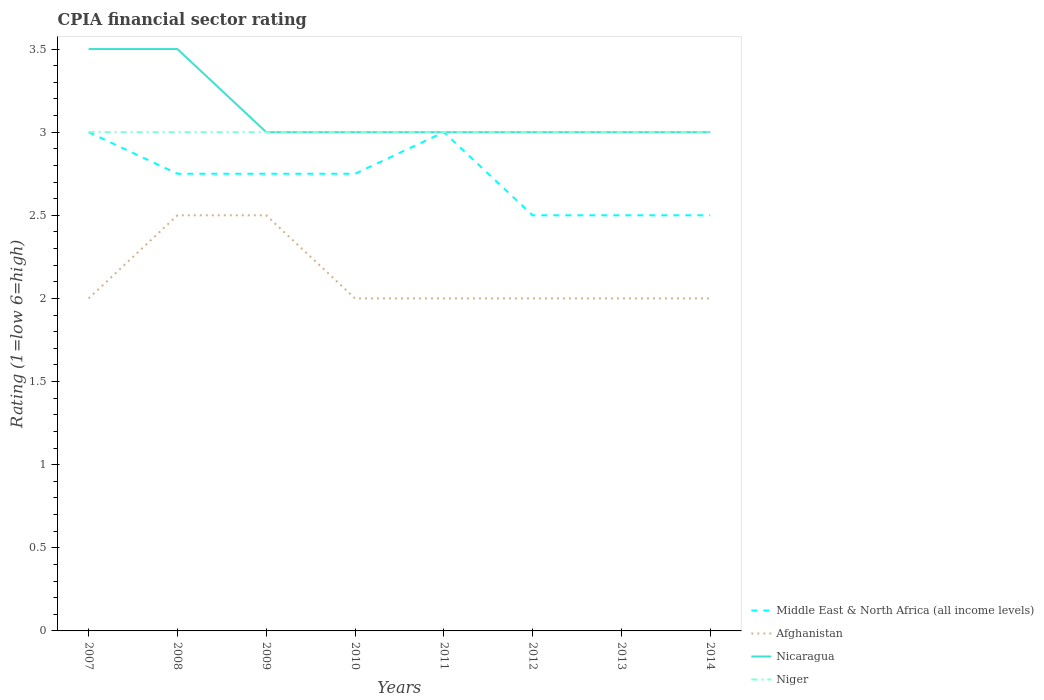How many different coloured lines are there?
Provide a succinct answer. 4. Does the line corresponding to Middle East & North Africa (all income levels) intersect with the line corresponding to Nicaragua?
Give a very brief answer. Yes. Is the number of lines equal to the number of legend labels?
Make the answer very short. Yes. Across all years, what is the maximum CPIA rating in Afghanistan?
Offer a terse response. 2. In which year was the CPIA rating in Nicaragua maximum?
Your response must be concise. 2009. What is the total CPIA rating in Niger in the graph?
Your answer should be compact. 0. Is the CPIA rating in Afghanistan strictly greater than the CPIA rating in Niger over the years?
Offer a terse response. Yes. How many lines are there?
Provide a succinct answer. 4. How many years are there in the graph?
Your response must be concise. 8. Are the values on the major ticks of Y-axis written in scientific E-notation?
Keep it short and to the point. No. Does the graph contain grids?
Your answer should be very brief. No. Where does the legend appear in the graph?
Give a very brief answer. Bottom right. What is the title of the graph?
Keep it short and to the point. CPIA financial sector rating. Does "Luxembourg" appear as one of the legend labels in the graph?
Offer a terse response. No. What is the label or title of the X-axis?
Offer a very short reply. Years. What is the label or title of the Y-axis?
Ensure brevity in your answer.  Rating (1=low 6=high). What is the Rating (1=low 6=high) in Middle East & North Africa (all income levels) in 2007?
Offer a terse response. 3. What is the Rating (1=low 6=high) in Afghanistan in 2007?
Ensure brevity in your answer.  2. What is the Rating (1=low 6=high) of Nicaragua in 2007?
Keep it short and to the point. 3.5. What is the Rating (1=low 6=high) of Middle East & North Africa (all income levels) in 2008?
Your answer should be compact. 2.75. What is the Rating (1=low 6=high) of Afghanistan in 2008?
Provide a succinct answer. 2.5. What is the Rating (1=low 6=high) of Nicaragua in 2008?
Your answer should be compact. 3.5. What is the Rating (1=low 6=high) of Middle East & North Africa (all income levels) in 2009?
Give a very brief answer. 2.75. What is the Rating (1=low 6=high) of Middle East & North Africa (all income levels) in 2010?
Make the answer very short. 2.75. What is the Rating (1=low 6=high) of Afghanistan in 2010?
Offer a very short reply. 2. What is the Rating (1=low 6=high) of Nicaragua in 2010?
Your response must be concise. 3. What is the Rating (1=low 6=high) in Niger in 2010?
Provide a succinct answer. 3. What is the Rating (1=low 6=high) of Afghanistan in 2011?
Provide a succinct answer. 2. What is the Rating (1=low 6=high) in Nicaragua in 2011?
Offer a terse response. 3. What is the Rating (1=low 6=high) in Middle East & North Africa (all income levels) in 2012?
Provide a succinct answer. 2.5. What is the Rating (1=low 6=high) of Nicaragua in 2012?
Offer a very short reply. 3. What is the Rating (1=low 6=high) in Nicaragua in 2013?
Keep it short and to the point. 3. What is the Rating (1=low 6=high) of Middle East & North Africa (all income levels) in 2014?
Ensure brevity in your answer.  2.5. What is the Rating (1=low 6=high) of Afghanistan in 2014?
Make the answer very short. 2. What is the Rating (1=low 6=high) in Nicaragua in 2014?
Your response must be concise. 3. Across all years, what is the maximum Rating (1=low 6=high) in Middle East & North Africa (all income levels)?
Give a very brief answer. 3. Across all years, what is the minimum Rating (1=low 6=high) in Afghanistan?
Your answer should be compact. 2. What is the total Rating (1=low 6=high) of Middle East & North Africa (all income levels) in the graph?
Provide a short and direct response. 21.75. What is the total Rating (1=low 6=high) of Afghanistan in the graph?
Your answer should be very brief. 17. What is the difference between the Rating (1=low 6=high) in Afghanistan in 2007 and that in 2008?
Offer a very short reply. -0.5. What is the difference between the Rating (1=low 6=high) in Nicaragua in 2007 and that in 2008?
Offer a terse response. 0. What is the difference between the Rating (1=low 6=high) of Niger in 2007 and that in 2008?
Offer a terse response. 0. What is the difference between the Rating (1=low 6=high) of Middle East & North Africa (all income levels) in 2007 and that in 2009?
Keep it short and to the point. 0.25. What is the difference between the Rating (1=low 6=high) of Niger in 2007 and that in 2009?
Give a very brief answer. 0. What is the difference between the Rating (1=low 6=high) in Middle East & North Africa (all income levels) in 2007 and that in 2010?
Your answer should be compact. 0.25. What is the difference between the Rating (1=low 6=high) of Afghanistan in 2007 and that in 2010?
Provide a succinct answer. 0. What is the difference between the Rating (1=low 6=high) of Niger in 2007 and that in 2010?
Provide a succinct answer. 0. What is the difference between the Rating (1=low 6=high) of Middle East & North Africa (all income levels) in 2007 and that in 2011?
Your response must be concise. 0. What is the difference between the Rating (1=low 6=high) of Afghanistan in 2007 and that in 2011?
Ensure brevity in your answer.  0. What is the difference between the Rating (1=low 6=high) in Afghanistan in 2007 and that in 2012?
Your answer should be compact. 0. What is the difference between the Rating (1=low 6=high) of Niger in 2007 and that in 2012?
Your answer should be compact. 0. What is the difference between the Rating (1=low 6=high) of Afghanistan in 2007 and that in 2013?
Keep it short and to the point. 0. What is the difference between the Rating (1=low 6=high) in Middle East & North Africa (all income levels) in 2007 and that in 2014?
Offer a terse response. 0.5. What is the difference between the Rating (1=low 6=high) of Afghanistan in 2007 and that in 2014?
Provide a short and direct response. 0. What is the difference between the Rating (1=low 6=high) in Nicaragua in 2007 and that in 2014?
Give a very brief answer. 0.5. What is the difference between the Rating (1=low 6=high) of Niger in 2007 and that in 2014?
Offer a terse response. 0. What is the difference between the Rating (1=low 6=high) in Nicaragua in 2008 and that in 2009?
Your response must be concise. 0.5. What is the difference between the Rating (1=low 6=high) in Middle East & North Africa (all income levels) in 2008 and that in 2010?
Your answer should be very brief. 0. What is the difference between the Rating (1=low 6=high) in Nicaragua in 2008 and that in 2010?
Your answer should be compact. 0.5. What is the difference between the Rating (1=low 6=high) in Niger in 2008 and that in 2010?
Make the answer very short. 0. What is the difference between the Rating (1=low 6=high) in Middle East & North Africa (all income levels) in 2008 and that in 2011?
Offer a very short reply. -0.25. What is the difference between the Rating (1=low 6=high) of Afghanistan in 2008 and that in 2011?
Your answer should be very brief. 0.5. What is the difference between the Rating (1=low 6=high) of Nicaragua in 2008 and that in 2011?
Ensure brevity in your answer.  0.5. What is the difference between the Rating (1=low 6=high) in Niger in 2008 and that in 2011?
Offer a terse response. 0. What is the difference between the Rating (1=low 6=high) of Middle East & North Africa (all income levels) in 2008 and that in 2013?
Make the answer very short. 0.25. What is the difference between the Rating (1=low 6=high) in Afghanistan in 2008 and that in 2014?
Ensure brevity in your answer.  0.5. What is the difference between the Rating (1=low 6=high) in Nicaragua in 2008 and that in 2014?
Provide a short and direct response. 0.5. What is the difference between the Rating (1=low 6=high) in Niger in 2008 and that in 2014?
Your response must be concise. 0. What is the difference between the Rating (1=low 6=high) of Afghanistan in 2009 and that in 2010?
Provide a succinct answer. 0.5. What is the difference between the Rating (1=low 6=high) in Niger in 2009 and that in 2010?
Keep it short and to the point. 0. What is the difference between the Rating (1=low 6=high) of Middle East & North Africa (all income levels) in 2009 and that in 2011?
Your response must be concise. -0.25. What is the difference between the Rating (1=low 6=high) of Nicaragua in 2009 and that in 2011?
Give a very brief answer. 0. What is the difference between the Rating (1=low 6=high) of Afghanistan in 2009 and that in 2012?
Make the answer very short. 0.5. What is the difference between the Rating (1=low 6=high) of Nicaragua in 2009 and that in 2012?
Provide a short and direct response. 0. What is the difference between the Rating (1=low 6=high) of Afghanistan in 2009 and that in 2013?
Your response must be concise. 0.5. What is the difference between the Rating (1=low 6=high) in Nicaragua in 2009 and that in 2013?
Give a very brief answer. 0. What is the difference between the Rating (1=low 6=high) in Afghanistan in 2009 and that in 2014?
Ensure brevity in your answer.  0.5. What is the difference between the Rating (1=low 6=high) in Nicaragua in 2009 and that in 2014?
Your response must be concise. 0. What is the difference between the Rating (1=low 6=high) in Middle East & North Africa (all income levels) in 2010 and that in 2011?
Your response must be concise. -0.25. What is the difference between the Rating (1=low 6=high) of Afghanistan in 2010 and that in 2011?
Provide a succinct answer. 0. What is the difference between the Rating (1=low 6=high) in Afghanistan in 2010 and that in 2012?
Keep it short and to the point. 0. What is the difference between the Rating (1=low 6=high) in Niger in 2010 and that in 2012?
Offer a very short reply. 0. What is the difference between the Rating (1=low 6=high) of Middle East & North Africa (all income levels) in 2010 and that in 2013?
Keep it short and to the point. 0.25. What is the difference between the Rating (1=low 6=high) of Afghanistan in 2010 and that in 2013?
Your answer should be very brief. 0. What is the difference between the Rating (1=low 6=high) of Nicaragua in 2010 and that in 2014?
Keep it short and to the point. 0. What is the difference between the Rating (1=low 6=high) of Niger in 2011 and that in 2012?
Your answer should be compact. 0. What is the difference between the Rating (1=low 6=high) in Afghanistan in 2011 and that in 2013?
Offer a very short reply. 0. What is the difference between the Rating (1=low 6=high) in Nicaragua in 2011 and that in 2013?
Your answer should be compact. 0. What is the difference between the Rating (1=low 6=high) of Middle East & North Africa (all income levels) in 2011 and that in 2014?
Offer a terse response. 0.5. What is the difference between the Rating (1=low 6=high) in Afghanistan in 2011 and that in 2014?
Your response must be concise. 0. What is the difference between the Rating (1=low 6=high) of Nicaragua in 2011 and that in 2014?
Give a very brief answer. 0. What is the difference between the Rating (1=low 6=high) of Niger in 2011 and that in 2014?
Ensure brevity in your answer.  0. What is the difference between the Rating (1=low 6=high) in Afghanistan in 2012 and that in 2013?
Your answer should be very brief. 0. What is the difference between the Rating (1=low 6=high) in Niger in 2012 and that in 2013?
Offer a very short reply. 0. What is the difference between the Rating (1=low 6=high) in Afghanistan in 2012 and that in 2014?
Provide a short and direct response. 0. What is the difference between the Rating (1=low 6=high) in Nicaragua in 2012 and that in 2014?
Provide a short and direct response. 0. What is the difference between the Rating (1=low 6=high) of Afghanistan in 2013 and that in 2014?
Your answer should be very brief. 0. What is the difference between the Rating (1=low 6=high) in Nicaragua in 2013 and that in 2014?
Your answer should be very brief. 0. What is the difference between the Rating (1=low 6=high) of Middle East & North Africa (all income levels) in 2007 and the Rating (1=low 6=high) of Niger in 2008?
Your response must be concise. 0. What is the difference between the Rating (1=low 6=high) in Afghanistan in 2007 and the Rating (1=low 6=high) in Niger in 2008?
Your answer should be compact. -1. What is the difference between the Rating (1=low 6=high) of Middle East & North Africa (all income levels) in 2007 and the Rating (1=low 6=high) of Afghanistan in 2009?
Ensure brevity in your answer.  0.5. What is the difference between the Rating (1=low 6=high) in Afghanistan in 2007 and the Rating (1=low 6=high) in Nicaragua in 2009?
Offer a terse response. -1. What is the difference between the Rating (1=low 6=high) of Afghanistan in 2007 and the Rating (1=low 6=high) of Niger in 2009?
Your answer should be very brief. -1. What is the difference between the Rating (1=low 6=high) of Nicaragua in 2007 and the Rating (1=low 6=high) of Niger in 2009?
Your answer should be compact. 0.5. What is the difference between the Rating (1=low 6=high) of Middle East & North Africa (all income levels) in 2007 and the Rating (1=low 6=high) of Niger in 2010?
Make the answer very short. 0. What is the difference between the Rating (1=low 6=high) in Afghanistan in 2007 and the Rating (1=low 6=high) in Nicaragua in 2010?
Offer a very short reply. -1. What is the difference between the Rating (1=low 6=high) in Nicaragua in 2007 and the Rating (1=low 6=high) in Niger in 2010?
Your response must be concise. 0.5. What is the difference between the Rating (1=low 6=high) in Middle East & North Africa (all income levels) in 2007 and the Rating (1=low 6=high) in Nicaragua in 2011?
Your answer should be very brief. 0. What is the difference between the Rating (1=low 6=high) of Afghanistan in 2007 and the Rating (1=low 6=high) of Nicaragua in 2011?
Your response must be concise. -1. What is the difference between the Rating (1=low 6=high) in Nicaragua in 2007 and the Rating (1=low 6=high) in Niger in 2011?
Give a very brief answer. 0.5. What is the difference between the Rating (1=low 6=high) in Middle East & North Africa (all income levels) in 2007 and the Rating (1=low 6=high) in Nicaragua in 2012?
Your response must be concise. 0. What is the difference between the Rating (1=low 6=high) of Afghanistan in 2007 and the Rating (1=low 6=high) of Nicaragua in 2012?
Offer a terse response. -1. What is the difference between the Rating (1=low 6=high) of Middle East & North Africa (all income levels) in 2007 and the Rating (1=low 6=high) of Nicaragua in 2013?
Provide a succinct answer. 0. What is the difference between the Rating (1=low 6=high) of Middle East & North Africa (all income levels) in 2007 and the Rating (1=low 6=high) of Nicaragua in 2014?
Make the answer very short. 0. What is the difference between the Rating (1=low 6=high) of Middle East & North Africa (all income levels) in 2007 and the Rating (1=low 6=high) of Niger in 2014?
Provide a short and direct response. 0. What is the difference between the Rating (1=low 6=high) of Afghanistan in 2007 and the Rating (1=low 6=high) of Nicaragua in 2014?
Your response must be concise. -1. What is the difference between the Rating (1=low 6=high) in Afghanistan in 2007 and the Rating (1=low 6=high) in Niger in 2014?
Offer a terse response. -1. What is the difference between the Rating (1=low 6=high) in Nicaragua in 2007 and the Rating (1=low 6=high) in Niger in 2014?
Your response must be concise. 0.5. What is the difference between the Rating (1=low 6=high) of Middle East & North Africa (all income levels) in 2008 and the Rating (1=low 6=high) of Nicaragua in 2009?
Offer a very short reply. -0.25. What is the difference between the Rating (1=low 6=high) in Afghanistan in 2008 and the Rating (1=low 6=high) in Niger in 2009?
Give a very brief answer. -0.5. What is the difference between the Rating (1=low 6=high) of Middle East & North Africa (all income levels) in 2008 and the Rating (1=low 6=high) of Nicaragua in 2010?
Ensure brevity in your answer.  -0.25. What is the difference between the Rating (1=low 6=high) of Middle East & North Africa (all income levels) in 2008 and the Rating (1=low 6=high) of Niger in 2010?
Provide a succinct answer. -0.25. What is the difference between the Rating (1=low 6=high) of Afghanistan in 2008 and the Rating (1=low 6=high) of Nicaragua in 2010?
Your answer should be very brief. -0.5. What is the difference between the Rating (1=low 6=high) in Afghanistan in 2008 and the Rating (1=low 6=high) in Niger in 2010?
Offer a terse response. -0.5. What is the difference between the Rating (1=low 6=high) in Middle East & North Africa (all income levels) in 2008 and the Rating (1=low 6=high) in Afghanistan in 2011?
Ensure brevity in your answer.  0.75. What is the difference between the Rating (1=low 6=high) of Middle East & North Africa (all income levels) in 2008 and the Rating (1=low 6=high) of Nicaragua in 2011?
Ensure brevity in your answer.  -0.25. What is the difference between the Rating (1=low 6=high) of Middle East & North Africa (all income levels) in 2008 and the Rating (1=low 6=high) of Niger in 2011?
Offer a very short reply. -0.25. What is the difference between the Rating (1=low 6=high) in Afghanistan in 2008 and the Rating (1=low 6=high) in Niger in 2012?
Offer a very short reply. -0.5. What is the difference between the Rating (1=low 6=high) in Middle East & North Africa (all income levels) in 2008 and the Rating (1=low 6=high) in Nicaragua in 2013?
Keep it short and to the point. -0.25. What is the difference between the Rating (1=low 6=high) of Afghanistan in 2008 and the Rating (1=low 6=high) of Nicaragua in 2013?
Provide a short and direct response. -0.5. What is the difference between the Rating (1=low 6=high) in Afghanistan in 2008 and the Rating (1=low 6=high) in Niger in 2013?
Make the answer very short. -0.5. What is the difference between the Rating (1=low 6=high) of Nicaragua in 2008 and the Rating (1=low 6=high) of Niger in 2013?
Offer a terse response. 0.5. What is the difference between the Rating (1=low 6=high) of Middle East & North Africa (all income levels) in 2008 and the Rating (1=low 6=high) of Afghanistan in 2014?
Offer a very short reply. 0.75. What is the difference between the Rating (1=low 6=high) of Middle East & North Africa (all income levels) in 2008 and the Rating (1=low 6=high) of Nicaragua in 2014?
Provide a short and direct response. -0.25. What is the difference between the Rating (1=low 6=high) of Middle East & North Africa (all income levels) in 2008 and the Rating (1=low 6=high) of Niger in 2014?
Provide a short and direct response. -0.25. What is the difference between the Rating (1=low 6=high) in Nicaragua in 2008 and the Rating (1=low 6=high) in Niger in 2014?
Provide a short and direct response. 0.5. What is the difference between the Rating (1=low 6=high) of Middle East & North Africa (all income levels) in 2009 and the Rating (1=low 6=high) of Nicaragua in 2010?
Offer a terse response. -0.25. What is the difference between the Rating (1=low 6=high) of Afghanistan in 2009 and the Rating (1=low 6=high) of Niger in 2010?
Offer a terse response. -0.5. What is the difference between the Rating (1=low 6=high) of Nicaragua in 2009 and the Rating (1=low 6=high) of Niger in 2010?
Make the answer very short. 0. What is the difference between the Rating (1=low 6=high) of Middle East & North Africa (all income levels) in 2009 and the Rating (1=low 6=high) of Afghanistan in 2011?
Offer a terse response. 0.75. What is the difference between the Rating (1=low 6=high) of Middle East & North Africa (all income levels) in 2009 and the Rating (1=low 6=high) of Nicaragua in 2011?
Provide a succinct answer. -0.25. What is the difference between the Rating (1=low 6=high) in Afghanistan in 2009 and the Rating (1=low 6=high) in Nicaragua in 2011?
Provide a succinct answer. -0.5. What is the difference between the Rating (1=low 6=high) in Afghanistan in 2009 and the Rating (1=low 6=high) in Niger in 2011?
Your answer should be very brief. -0.5. What is the difference between the Rating (1=low 6=high) of Nicaragua in 2009 and the Rating (1=low 6=high) of Niger in 2011?
Keep it short and to the point. 0. What is the difference between the Rating (1=low 6=high) in Middle East & North Africa (all income levels) in 2009 and the Rating (1=low 6=high) in Afghanistan in 2012?
Offer a very short reply. 0.75. What is the difference between the Rating (1=low 6=high) in Middle East & North Africa (all income levels) in 2009 and the Rating (1=low 6=high) in Nicaragua in 2012?
Offer a terse response. -0.25. What is the difference between the Rating (1=low 6=high) of Middle East & North Africa (all income levels) in 2009 and the Rating (1=low 6=high) of Niger in 2012?
Give a very brief answer. -0.25. What is the difference between the Rating (1=low 6=high) of Afghanistan in 2009 and the Rating (1=low 6=high) of Nicaragua in 2012?
Your answer should be compact. -0.5. What is the difference between the Rating (1=low 6=high) of Nicaragua in 2009 and the Rating (1=low 6=high) of Niger in 2012?
Offer a very short reply. 0. What is the difference between the Rating (1=low 6=high) in Middle East & North Africa (all income levels) in 2009 and the Rating (1=low 6=high) in Afghanistan in 2013?
Your answer should be very brief. 0.75. What is the difference between the Rating (1=low 6=high) of Middle East & North Africa (all income levels) in 2009 and the Rating (1=low 6=high) of Nicaragua in 2013?
Your response must be concise. -0.25. What is the difference between the Rating (1=low 6=high) of Middle East & North Africa (all income levels) in 2009 and the Rating (1=low 6=high) of Niger in 2013?
Your response must be concise. -0.25. What is the difference between the Rating (1=low 6=high) of Afghanistan in 2009 and the Rating (1=low 6=high) of Nicaragua in 2013?
Keep it short and to the point. -0.5. What is the difference between the Rating (1=low 6=high) in Nicaragua in 2009 and the Rating (1=low 6=high) in Niger in 2013?
Offer a terse response. 0. What is the difference between the Rating (1=low 6=high) of Middle East & North Africa (all income levels) in 2009 and the Rating (1=low 6=high) of Niger in 2014?
Your answer should be very brief. -0.25. What is the difference between the Rating (1=low 6=high) in Middle East & North Africa (all income levels) in 2010 and the Rating (1=low 6=high) in Nicaragua in 2011?
Provide a short and direct response. -0.25. What is the difference between the Rating (1=low 6=high) in Middle East & North Africa (all income levels) in 2010 and the Rating (1=low 6=high) in Niger in 2011?
Provide a short and direct response. -0.25. What is the difference between the Rating (1=low 6=high) of Afghanistan in 2010 and the Rating (1=low 6=high) of Niger in 2011?
Your answer should be very brief. -1. What is the difference between the Rating (1=low 6=high) of Middle East & North Africa (all income levels) in 2010 and the Rating (1=low 6=high) of Niger in 2012?
Offer a terse response. -0.25. What is the difference between the Rating (1=low 6=high) of Afghanistan in 2010 and the Rating (1=low 6=high) of Nicaragua in 2012?
Keep it short and to the point. -1. What is the difference between the Rating (1=low 6=high) of Nicaragua in 2010 and the Rating (1=low 6=high) of Niger in 2012?
Your response must be concise. 0. What is the difference between the Rating (1=low 6=high) of Middle East & North Africa (all income levels) in 2010 and the Rating (1=low 6=high) of Afghanistan in 2013?
Provide a short and direct response. 0.75. What is the difference between the Rating (1=low 6=high) in Afghanistan in 2010 and the Rating (1=low 6=high) in Nicaragua in 2013?
Your answer should be very brief. -1. What is the difference between the Rating (1=low 6=high) of Afghanistan in 2010 and the Rating (1=low 6=high) of Niger in 2013?
Your answer should be very brief. -1. What is the difference between the Rating (1=low 6=high) of Middle East & North Africa (all income levels) in 2010 and the Rating (1=low 6=high) of Nicaragua in 2014?
Your response must be concise. -0.25. What is the difference between the Rating (1=low 6=high) in Afghanistan in 2010 and the Rating (1=low 6=high) in Nicaragua in 2014?
Your answer should be very brief. -1. What is the difference between the Rating (1=low 6=high) of Middle East & North Africa (all income levels) in 2011 and the Rating (1=low 6=high) of Afghanistan in 2012?
Provide a short and direct response. 1. What is the difference between the Rating (1=low 6=high) in Middle East & North Africa (all income levels) in 2011 and the Rating (1=low 6=high) in Nicaragua in 2012?
Ensure brevity in your answer.  0. What is the difference between the Rating (1=low 6=high) in Middle East & North Africa (all income levels) in 2011 and the Rating (1=low 6=high) in Nicaragua in 2014?
Make the answer very short. 0. What is the difference between the Rating (1=low 6=high) in Middle East & North Africa (all income levels) in 2011 and the Rating (1=low 6=high) in Niger in 2014?
Offer a terse response. 0. What is the difference between the Rating (1=low 6=high) in Afghanistan in 2011 and the Rating (1=low 6=high) in Nicaragua in 2014?
Provide a succinct answer. -1. What is the difference between the Rating (1=low 6=high) in Nicaragua in 2011 and the Rating (1=low 6=high) in Niger in 2014?
Keep it short and to the point. 0. What is the difference between the Rating (1=low 6=high) in Middle East & North Africa (all income levels) in 2012 and the Rating (1=low 6=high) in Afghanistan in 2013?
Provide a short and direct response. 0.5. What is the difference between the Rating (1=low 6=high) of Middle East & North Africa (all income levels) in 2012 and the Rating (1=low 6=high) of Nicaragua in 2013?
Provide a short and direct response. -0.5. What is the difference between the Rating (1=low 6=high) of Middle East & North Africa (all income levels) in 2012 and the Rating (1=low 6=high) of Niger in 2013?
Your answer should be very brief. -0.5. What is the difference between the Rating (1=low 6=high) of Afghanistan in 2012 and the Rating (1=low 6=high) of Nicaragua in 2013?
Keep it short and to the point. -1. What is the difference between the Rating (1=low 6=high) of Afghanistan in 2012 and the Rating (1=low 6=high) of Niger in 2013?
Keep it short and to the point. -1. What is the difference between the Rating (1=low 6=high) in Middle East & North Africa (all income levels) in 2012 and the Rating (1=low 6=high) in Niger in 2014?
Your answer should be very brief. -0.5. What is the difference between the Rating (1=low 6=high) in Nicaragua in 2012 and the Rating (1=low 6=high) in Niger in 2014?
Make the answer very short. 0. What is the difference between the Rating (1=low 6=high) of Middle East & North Africa (all income levels) in 2013 and the Rating (1=low 6=high) of Niger in 2014?
Your answer should be compact. -0.5. What is the difference between the Rating (1=low 6=high) in Afghanistan in 2013 and the Rating (1=low 6=high) in Nicaragua in 2014?
Your answer should be compact. -1. What is the difference between the Rating (1=low 6=high) of Nicaragua in 2013 and the Rating (1=low 6=high) of Niger in 2014?
Give a very brief answer. 0. What is the average Rating (1=low 6=high) in Middle East & North Africa (all income levels) per year?
Your answer should be very brief. 2.72. What is the average Rating (1=low 6=high) in Afghanistan per year?
Ensure brevity in your answer.  2.12. What is the average Rating (1=low 6=high) in Nicaragua per year?
Provide a short and direct response. 3.12. What is the average Rating (1=low 6=high) in Niger per year?
Your answer should be very brief. 3. In the year 2007, what is the difference between the Rating (1=low 6=high) in Middle East & North Africa (all income levels) and Rating (1=low 6=high) in Afghanistan?
Keep it short and to the point. 1. In the year 2007, what is the difference between the Rating (1=low 6=high) in Middle East & North Africa (all income levels) and Rating (1=low 6=high) in Niger?
Your answer should be very brief. 0. In the year 2007, what is the difference between the Rating (1=low 6=high) in Afghanistan and Rating (1=low 6=high) in Nicaragua?
Offer a very short reply. -1.5. In the year 2007, what is the difference between the Rating (1=low 6=high) in Afghanistan and Rating (1=low 6=high) in Niger?
Make the answer very short. -1. In the year 2007, what is the difference between the Rating (1=low 6=high) in Nicaragua and Rating (1=low 6=high) in Niger?
Your response must be concise. 0.5. In the year 2008, what is the difference between the Rating (1=low 6=high) in Middle East & North Africa (all income levels) and Rating (1=low 6=high) in Afghanistan?
Provide a succinct answer. 0.25. In the year 2008, what is the difference between the Rating (1=low 6=high) of Middle East & North Africa (all income levels) and Rating (1=low 6=high) of Nicaragua?
Your answer should be very brief. -0.75. In the year 2008, what is the difference between the Rating (1=low 6=high) of Afghanistan and Rating (1=low 6=high) of Nicaragua?
Your response must be concise. -1. In the year 2008, what is the difference between the Rating (1=low 6=high) of Afghanistan and Rating (1=low 6=high) of Niger?
Your answer should be compact. -0.5. In the year 2009, what is the difference between the Rating (1=low 6=high) of Middle East & North Africa (all income levels) and Rating (1=low 6=high) of Afghanistan?
Provide a succinct answer. 0.25. In the year 2009, what is the difference between the Rating (1=low 6=high) in Middle East & North Africa (all income levels) and Rating (1=low 6=high) in Niger?
Provide a succinct answer. -0.25. In the year 2009, what is the difference between the Rating (1=low 6=high) in Afghanistan and Rating (1=low 6=high) in Niger?
Offer a very short reply. -0.5. In the year 2009, what is the difference between the Rating (1=low 6=high) in Nicaragua and Rating (1=low 6=high) in Niger?
Offer a very short reply. 0. In the year 2010, what is the difference between the Rating (1=low 6=high) in Middle East & North Africa (all income levels) and Rating (1=low 6=high) in Niger?
Offer a very short reply. -0.25. In the year 2010, what is the difference between the Rating (1=low 6=high) of Afghanistan and Rating (1=low 6=high) of Nicaragua?
Provide a succinct answer. -1. In the year 2010, what is the difference between the Rating (1=low 6=high) of Afghanistan and Rating (1=low 6=high) of Niger?
Your answer should be compact. -1. In the year 2010, what is the difference between the Rating (1=low 6=high) of Nicaragua and Rating (1=low 6=high) of Niger?
Provide a succinct answer. 0. In the year 2011, what is the difference between the Rating (1=low 6=high) of Middle East & North Africa (all income levels) and Rating (1=low 6=high) of Afghanistan?
Make the answer very short. 1. In the year 2011, what is the difference between the Rating (1=low 6=high) of Middle East & North Africa (all income levels) and Rating (1=low 6=high) of Niger?
Provide a succinct answer. 0. In the year 2011, what is the difference between the Rating (1=low 6=high) in Afghanistan and Rating (1=low 6=high) in Nicaragua?
Give a very brief answer. -1. In the year 2011, what is the difference between the Rating (1=low 6=high) in Nicaragua and Rating (1=low 6=high) in Niger?
Offer a terse response. 0. In the year 2012, what is the difference between the Rating (1=low 6=high) in Middle East & North Africa (all income levels) and Rating (1=low 6=high) in Afghanistan?
Provide a succinct answer. 0.5. In the year 2012, what is the difference between the Rating (1=low 6=high) in Afghanistan and Rating (1=low 6=high) in Nicaragua?
Offer a terse response. -1. In the year 2012, what is the difference between the Rating (1=low 6=high) of Afghanistan and Rating (1=low 6=high) of Niger?
Your response must be concise. -1. In the year 2013, what is the difference between the Rating (1=low 6=high) in Middle East & North Africa (all income levels) and Rating (1=low 6=high) in Nicaragua?
Offer a terse response. -0.5. In the year 2013, what is the difference between the Rating (1=low 6=high) in Middle East & North Africa (all income levels) and Rating (1=low 6=high) in Niger?
Your answer should be very brief. -0.5. In the year 2013, what is the difference between the Rating (1=low 6=high) of Afghanistan and Rating (1=low 6=high) of Nicaragua?
Provide a short and direct response. -1. In the year 2013, what is the difference between the Rating (1=low 6=high) in Nicaragua and Rating (1=low 6=high) in Niger?
Your answer should be compact. 0. In the year 2014, what is the difference between the Rating (1=low 6=high) in Middle East & North Africa (all income levels) and Rating (1=low 6=high) in Afghanistan?
Your answer should be compact. 0.5. In the year 2014, what is the difference between the Rating (1=low 6=high) in Middle East & North Africa (all income levels) and Rating (1=low 6=high) in Nicaragua?
Keep it short and to the point. -0.5. In the year 2014, what is the difference between the Rating (1=low 6=high) in Afghanistan and Rating (1=low 6=high) in Niger?
Offer a terse response. -1. What is the ratio of the Rating (1=low 6=high) in Middle East & North Africa (all income levels) in 2007 to that in 2008?
Offer a terse response. 1.09. What is the ratio of the Rating (1=low 6=high) of Afghanistan in 2007 to that in 2008?
Provide a succinct answer. 0.8. What is the ratio of the Rating (1=low 6=high) of Nicaragua in 2007 to that in 2008?
Ensure brevity in your answer.  1. What is the ratio of the Rating (1=low 6=high) in Middle East & North Africa (all income levels) in 2007 to that in 2009?
Offer a very short reply. 1.09. What is the ratio of the Rating (1=low 6=high) in Afghanistan in 2007 to that in 2009?
Give a very brief answer. 0.8. What is the ratio of the Rating (1=low 6=high) in Middle East & North Africa (all income levels) in 2007 to that in 2010?
Offer a terse response. 1.09. What is the ratio of the Rating (1=low 6=high) in Niger in 2007 to that in 2010?
Provide a short and direct response. 1. What is the ratio of the Rating (1=low 6=high) of Afghanistan in 2007 to that in 2011?
Your answer should be compact. 1. What is the ratio of the Rating (1=low 6=high) of Niger in 2007 to that in 2011?
Your response must be concise. 1. What is the ratio of the Rating (1=low 6=high) in Middle East & North Africa (all income levels) in 2007 to that in 2013?
Your response must be concise. 1.2. What is the ratio of the Rating (1=low 6=high) of Afghanistan in 2007 to that in 2013?
Keep it short and to the point. 1. What is the ratio of the Rating (1=low 6=high) of Nicaragua in 2007 to that in 2013?
Offer a terse response. 1.17. What is the ratio of the Rating (1=low 6=high) in Nicaragua in 2007 to that in 2014?
Your answer should be compact. 1.17. What is the ratio of the Rating (1=low 6=high) in Niger in 2007 to that in 2014?
Offer a terse response. 1. What is the ratio of the Rating (1=low 6=high) in Afghanistan in 2008 to that in 2009?
Offer a terse response. 1. What is the ratio of the Rating (1=low 6=high) of Nicaragua in 2008 to that in 2009?
Offer a terse response. 1.17. What is the ratio of the Rating (1=low 6=high) in Niger in 2008 to that in 2009?
Offer a terse response. 1. What is the ratio of the Rating (1=low 6=high) of Afghanistan in 2008 to that in 2010?
Offer a very short reply. 1.25. What is the ratio of the Rating (1=low 6=high) in Nicaragua in 2008 to that in 2010?
Provide a succinct answer. 1.17. What is the ratio of the Rating (1=low 6=high) in Middle East & North Africa (all income levels) in 2008 to that in 2011?
Offer a very short reply. 0.92. What is the ratio of the Rating (1=low 6=high) in Nicaragua in 2008 to that in 2011?
Your response must be concise. 1.17. What is the ratio of the Rating (1=low 6=high) in Afghanistan in 2008 to that in 2012?
Your response must be concise. 1.25. What is the ratio of the Rating (1=low 6=high) of Nicaragua in 2008 to that in 2012?
Offer a very short reply. 1.17. What is the ratio of the Rating (1=low 6=high) of Niger in 2008 to that in 2012?
Your answer should be compact. 1. What is the ratio of the Rating (1=low 6=high) of Afghanistan in 2008 to that in 2013?
Offer a very short reply. 1.25. What is the ratio of the Rating (1=low 6=high) in Niger in 2008 to that in 2013?
Give a very brief answer. 1. What is the ratio of the Rating (1=low 6=high) of Nicaragua in 2008 to that in 2014?
Your answer should be very brief. 1.17. What is the ratio of the Rating (1=low 6=high) of Afghanistan in 2009 to that in 2010?
Your response must be concise. 1.25. What is the ratio of the Rating (1=low 6=high) of Niger in 2009 to that in 2010?
Ensure brevity in your answer.  1. What is the ratio of the Rating (1=low 6=high) in Middle East & North Africa (all income levels) in 2009 to that in 2011?
Make the answer very short. 0.92. What is the ratio of the Rating (1=low 6=high) in Afghanistan in 2009 to that in 2011?
Your answer should be very brief. 1.25. What is the ratio of the Rating (1=low 6=high) in Nicaragua in 2009 to that in 2011?
Give a very brief answer. 1. What is the ratio of the Rating (1=low 6=high) of Nicaragua in 2009 to that in 2012?
Keep it short and to the point. 1. What is the ratio of the Rating (1=low 6=high) in Niger in 2009 to that in 2012?
Provide a succinct answer. 1. What is the ratio of the Rating (1=low 6=high) of Middle East & North Africa (all income levels) in 2009 to that in 2013?
Offer a very short reply. 1.1. What is the ratio of the Rating (1=low 6=high) of Niger in 2009 to that in 2013?
Make the answer very short. 1. What is the ratio of the Rating (1=low 6=high) of Middle East & North Africa (all income levels) in 2009 to that in 2014?
Offer a terse response. 1.1. What is the ratio of the Rating (1=low 6=high) in Nicaragua in 2009 to that in 2014?
Provide a short and direct response. 1. What is the ratio of the Rating (1=low 6=high) in Niger in 2009 to that in 2014?
Make the answer very short. 1. What is the ratio of the Rating (1=low 6=high) of Afghanistan in 2010 to that in 2011?
Keep it short and to the point. 1. What is the ratio of the Rating (1=low 6=high) in Nicaragua in 2010 to that in 2011?
Make the answer very short. 1. What is the ratio of the Rating (1=low 6=high) in Niger in 2010 to that in 2011?
Provide a short and direct response. 1. What is the ratio of the Rating (1=low 6=high) in Afghanistan in 2010 to that in 2012?
Provide a succinct answer. 1. What is the ratio of the Rating (1=low 6=high) in Nicaragua in 2010 to that in 2013?
Your answer should be very brief. 1. What is the ratio of the Rating (1=low 6=high) of Niger in 2010 to that in 2013?
Keep it short and to the point. 1. What is the ratio of the Rating (1=low 6=high) of Middle East & North Africa (all income levels) in 2010 to that in 2014?
Keep it short and to the point. 1.1. What is the ratio of the Rating (1=low 6=high) in Middle East & North Africa (all income levels) in 2011 to that in 2012?
Your answer should be compact. 1.2. What is the ratio of the Rating (1=low 6=high) of Nicaragua in 2011 to that in 2012?
Provide a short and direct response. 1. What is the ratio of the Rating (1=low 6=high) in Niger in 2011 to that in 2012?
Your answer should be compact. 1. What is the ratio of the Rating (1=low 6=high) of Middle East & North Africa (all income levels) in 2011 to that in 2013?
Your answer should be very brief. 1.2. What is the ratio of the Rating (1=low 6=high) of Afghanistan in 2011 to that in 2013?
Ensure brevity in your answer.  1. What is the ratio of the Rating (1=low 6=high) in Nicaragua in 2011 to that in 2013?
Provide a short and direct response. 1. What is the ratio of the Rating (1=low 6=high) in Afghanistan in 2011 to that in 2014?
Your response must be concise. 1. What is the ratio of the Rating (1=low 6=high) in Nicaragua in 2011 to that in 2014?
Make the answer very short. 1. What is the ratio of the Rating (1=low 6=high) in Niger in 2011 to that in 2014?
Ensure brevity in your answer.  1. What is the ratio of the Rating (1=low 6=high) of Nicaragua in 2012 to that in 2013?
Provide a succinct answer. 1. What is the ratio of the Rating (1=low 6=high) in Niger in 2012 to that in 2013?
Offer a terse response. 1. What is the ratio of the Rating (1=low 6=high) in Middle East & North Africa (all income levels) in 2012 to that in 2014?
Your response must be concise. 1. What is the ratio of the Rating (1=low 6=high) in Afghanistan in 2012 to that in 2014?
Ensure brevity in your answer.  1. What is the ratio of the Rating (1=low 6=high) in Nicaragua in 2012 to that in 2014?
Your answer should be very brief. 1. What is the ratio of the Rating (1=low 6=high) in Middle East & North Africa (all income levels) in 2013 to that in 2014?
Offer a very short reply. 1. What is the ratio of the Rating (1=low 6=high) in Nicaragua in 2013 to that in 2014?
Your response must be concise. 1. What is the ratio of the Rating (1=low 6=high) in Niger in 2013 to that in 2014?
Your answer should be very brief. 1. What is the difference between the highest and the second highest Rating (1=low 6=high) in Afghanistan?
Keep it short and to the point. 0. What is the difference between the highest and the second highest Rating (1=low 6=high) of Nicaragua?
Your answer should be very brief. 0. What is the difference between the highest and the lowest Rating (1=low 6=high) of Nicaragua?
Provide a short and direct response. 0.5. What is the difference between the highest and the lowest Rating (1=low 6=high) of Niger?
Offer a very short reply. 0. 